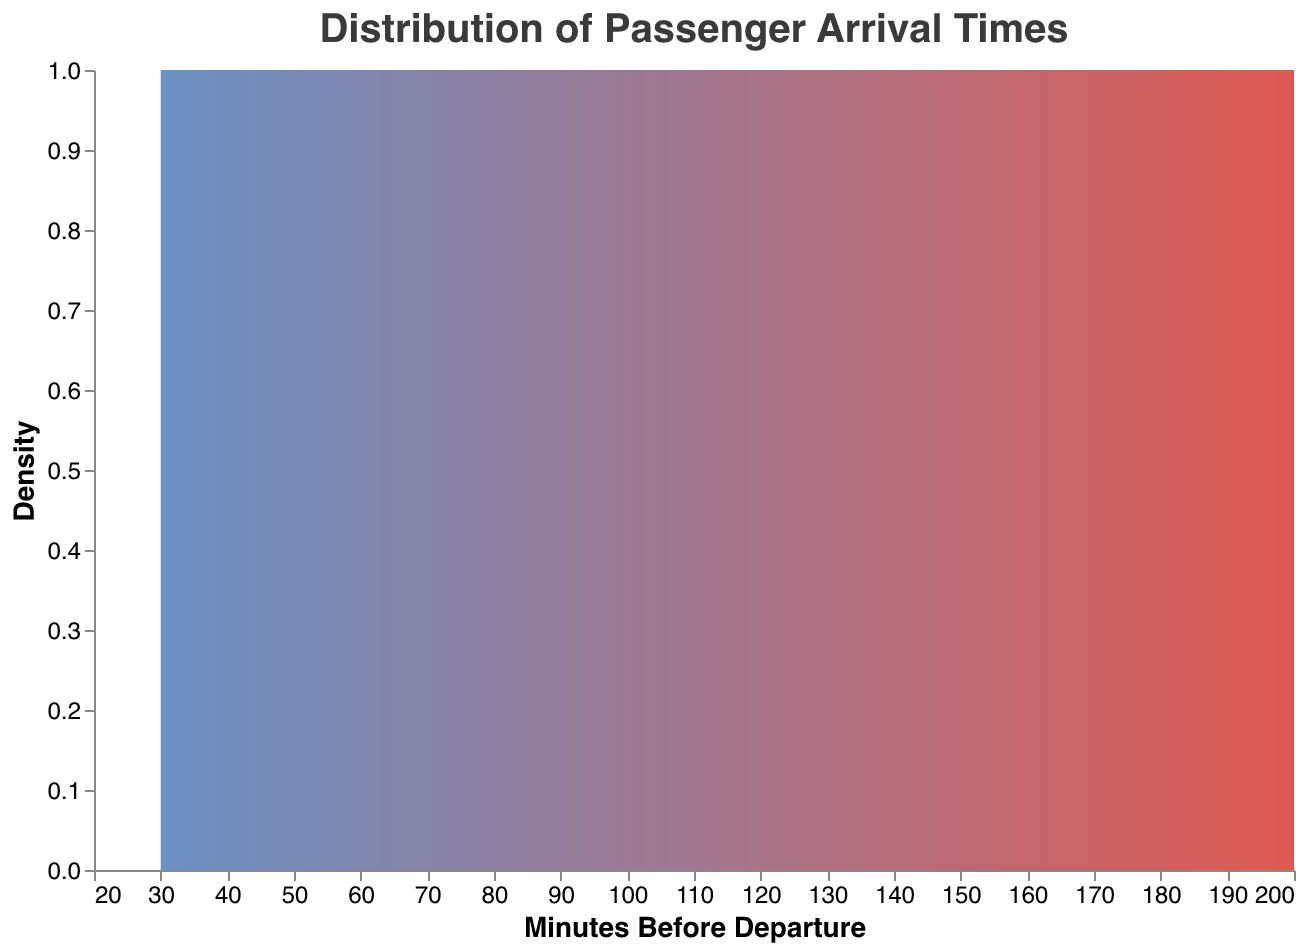What is the title of the figure? The title is usually located at the top of the figure. It gives a brief description of what the plot represents.
Answer: "Distribution of Passenger Arrival Times" What is the color gradient used in the density plot? The color gradient can be observed on the plot, transitioning from one color to another.
Answer: Blue to red What are the labels on the x-axis and y-axis? The x-axis and y-axis labels provide information about what the respective axes represent.
Answer: "Minutes Before Departure" and "Density" What is the arrival time with the highest density? To find the arrival time with the highest density, look for the peak of the density plot on the x-axis. This point represents where the most passengers arrived.
Answer: Around 100 minutes before departure At which approximate arrival time does the density significantly start to decrease? Find the point on the plot where it starts sloping downward after the peak. This indicates a drop in the number of passengers arriving around that time.
Answer: Around 110 minutes before departure What is the range of arrival times covered in this plot? The range can be determined by looking at the minimum and maximum tick values on the x-axis.
Answer: 30 to 200 minutes before departure How does the density of passengers arriving 90 minutes before departure compare to those arriving 150 minutes before departure? Compare the heights of the density plot at 90 and 150 minutes before departure. This tells us which time had a higher density (more passengers arriving).
Answer: The density is higher at 90 minutes before departure What is the approximate density for passengers arriving 50 minutes before departure? Find the y-value on the plot corresponding to the x-value of 50 minutes before departure.
Answer: Low density Is the distribution of arrival times symmetrical around the peak? Examine the shape of the density plot on both sides of the peak to determine if it is approximately mirrored.
Answer: No, it is skewed to the right What can you infer about passenger behavior based on the density plot? This requires interpreting the overall shape of the density plot and peaks to make inferences about how early most passengers arrive.
Answer: Most passengers arrive around 90-120 minutes before departure, with fewer arriving significantly earlier or later 